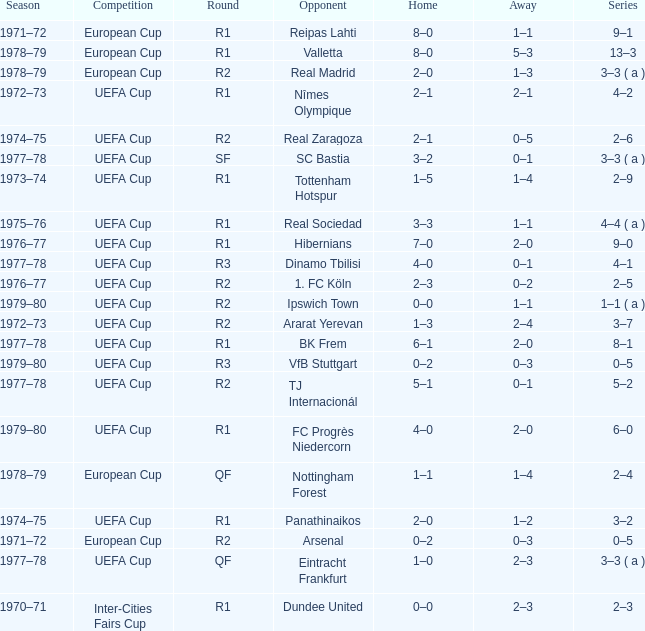Which Round has a Competition of uefa cup, and a Series of 5–2? R2. 